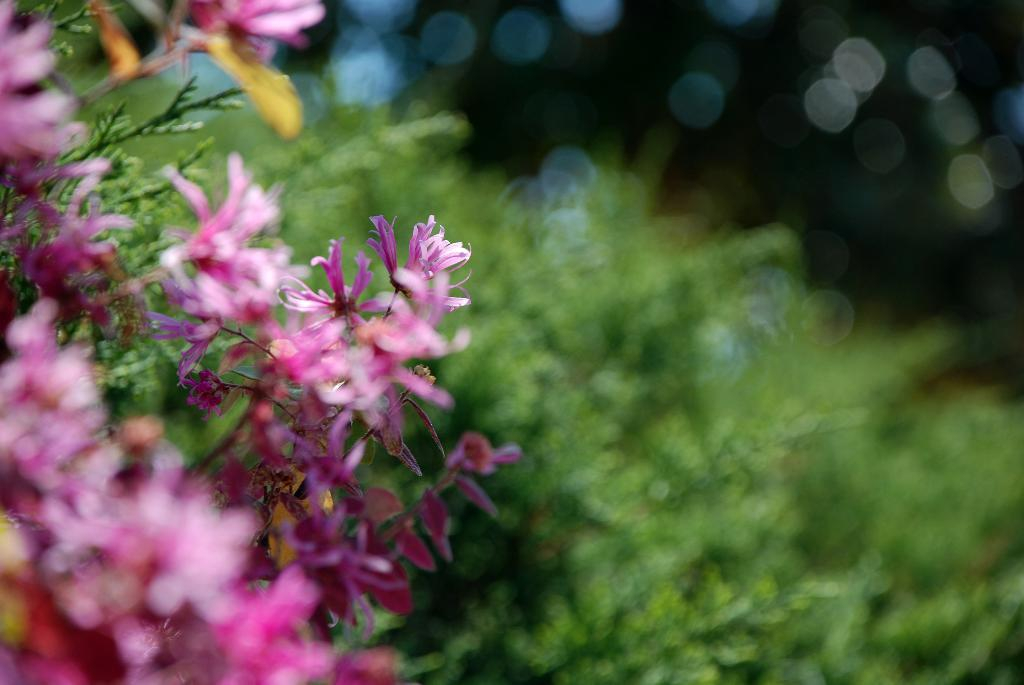What type of flora can be seen in the foreground of the image? There are flowers in the foreground of the image. What type of flora can be seen in the background of the image? There are plants in the background of the image. What type of noise can be heard coming from the flowers in the image? There is no noise coming from the flowers in the image, as flowers do not produce sound. 